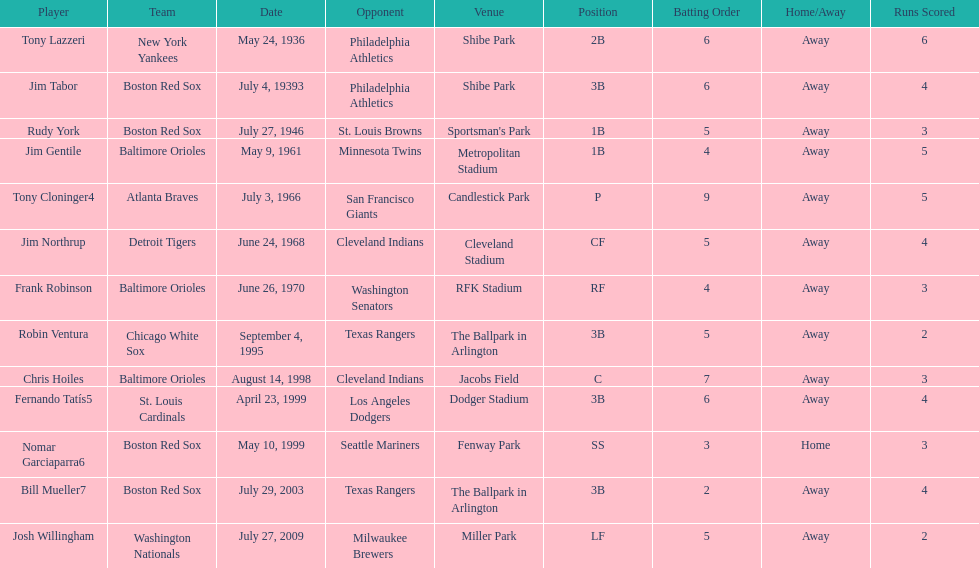Who was the opponent for the boston red sox on july 27, 1946? St. Louis Browns. 